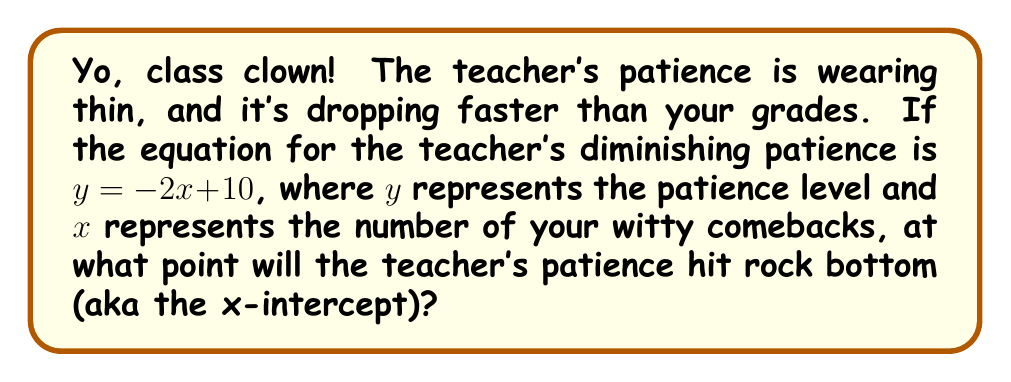Provide a solution to this math problem. Alright, fellow troublemaker, let's break this down:

1) The x-intercept is where the line crosses the x-axis, meaning where $y = 0$.

2) We start with the equation: $y = -2x + 10$

3) To find the x-intercept, we set $y = 0$:
   
   $0 = -2x + 10$

4) Now, let's solve for $x$:
   
   $2x = 10$
   
   $x = 5$

5) To verify, we can plug this back into the original equation:
   
   $y = -2(5) + 10 = -10 + 10 = 0$

So, after 5 of your killer comebacks, the teacher's patience will flatline at the x-axis.
Answer: $x = 5$ 